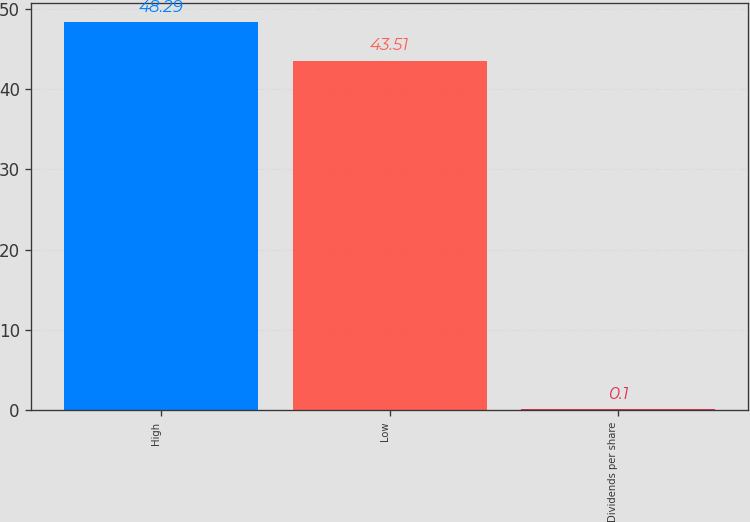Convert chart to OTSL. <chart><loc_0><loc_0><loc_500><loc_500><bar_chart><fcel>High<fcel>Low<fcel>Dividends per share<nl><fcel>48.29<fcel>43.51<fcel>0.1<nl></chart> 